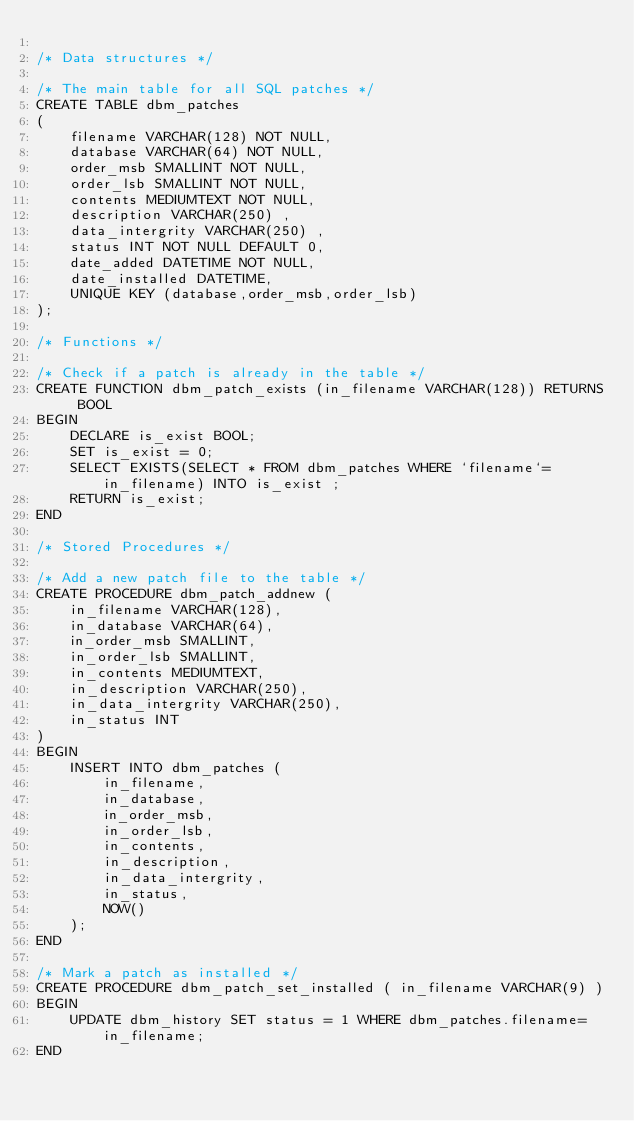Convert code to text. <code><loc_0><loc_0><loc_500><loc_500><_SQL_>
/* Data structures */

/* The main table for all SQL patches */
CREATE TABLE dbm_patches
(
	filename VARCHAR(128) NOT NULL,
	database VARCHAR(64) NOT NULL,
	order_msb SMALLINT NOT NULL,
	order_lsb SMALLINT NOT NULL,
	contents MEDIUMTEXT NOT NULL,
	description VARCHAR(250) ,
	data_intergrity VARCHAR(250) ,
	status INT NOT NULL DEFAULT 0,
	date_added DATETIME NOT NULL,
	date_installed DATETIME,
	UNIQUE KEY (database,order_msb,order_lsb)
);

/* Functions */

/* Check if a patch is already in the table */
CREATE FUNCTION dbm_patch_exists (in_filename VARCHAR(128)) RETURNS BOOL
BEGIN
    DECLARE is_exist BOOL;
    SET is_exist = 0;
    SELECT EXISTS(SELECT * FROM dbm_patches WHERE `filename`=in_filename) INTO is_exist ;
    RETURN is_exist;
END

/* Stored Procedures */

/* Add a new patch file to the table */
CREATE PROCEDURE dbm_patch_addnew (
	in_filename VARCHAR(128),
	in_database VARCHAR(64),
	in_order_msb SMALLINT,
	in_order_lsb SMALLINT,
	in_contents MEDIUMTEXT,
	in_description VARCHAR(250),
	in_data_intergrity VARCHAR(250),
	in_status INT
)
BEGIN
	INSERT INTO dbm_patches (
		in_filename,
		in_database,
		in_order_msb,
		in_order_lsb,
		in_contents,
		in_description,
		in_data_intergrity,
		in_status,
		NOW()
	);
END

/* Mark a patch as installed */
CREATE PROCEDURE dbm_patch_set_installed ( in_filename VARCHAR(9) )
BEGIN
	UPDATE dbm_history SET status = 1 WHERE dbm_patches.filename=in_filename;
END


</code> 